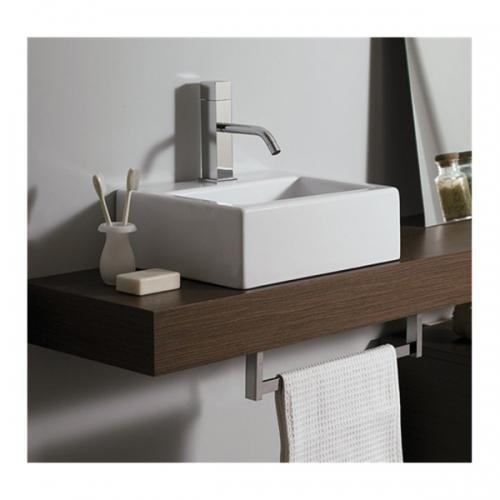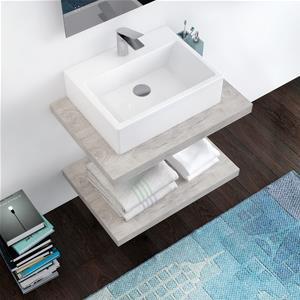The first image is the image on the left, the second image is the image on the right. Analyze the images presented: Is the assertion "One image shows a square white sink with a single upright chrome faucet fixture on it, atop a brown plank-type counter." valid? Answer yes or no. Yes. The first image is the image on the left, the second image is the image on the right. For the images shown, is this caption "Both of the basins are rectangular shaped." true? Answer yes or no. Yes. 